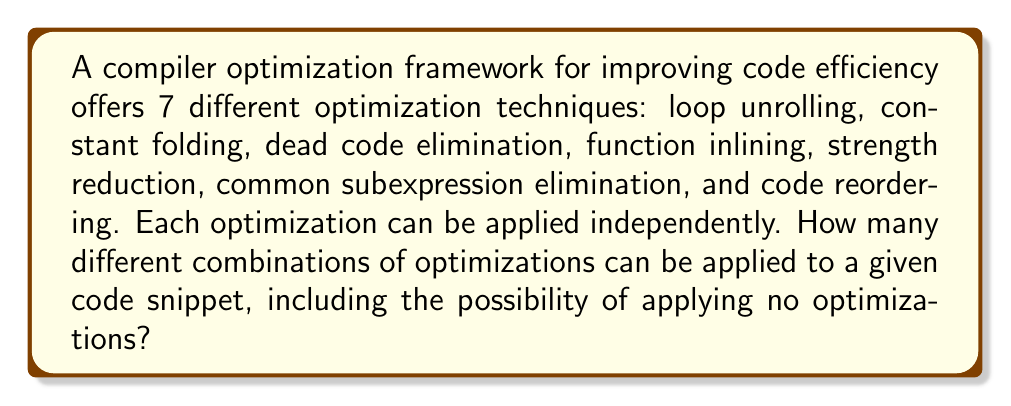Teach me how to tackle this problem. Let's approach this step-by-step:

1) For each optimization technique, we have two choices: either apply it or not apply it.

2) This scenario is a perfect example of the multiplication principle in combinatorics.

3) For each of the 7 optimization techniques, we have 2 choices.

4) Therefore, the total number of possible combinations is:

   $$2 \times 2 \times 2 \times 2 \times 2 \times 2 \times 2 = 2^7$$

5) This can be interpreted as:
   - 2 choices for loop unrolling
   - 2 choices for constant folding
   - 2 choices for dead code elimination
   - 2 choices for function inlining
   - 2 choices for strength reduction
   - 2 choices for common subexpression elimination
   - 2 choices for code reordering

6) The $2^7$ combinations include the case where no optimizations are applied (all 7 techniques are not chosen).

7) Therefore, the total number of possible combinations is $2^7 = 128$.
Answer: $128$ 